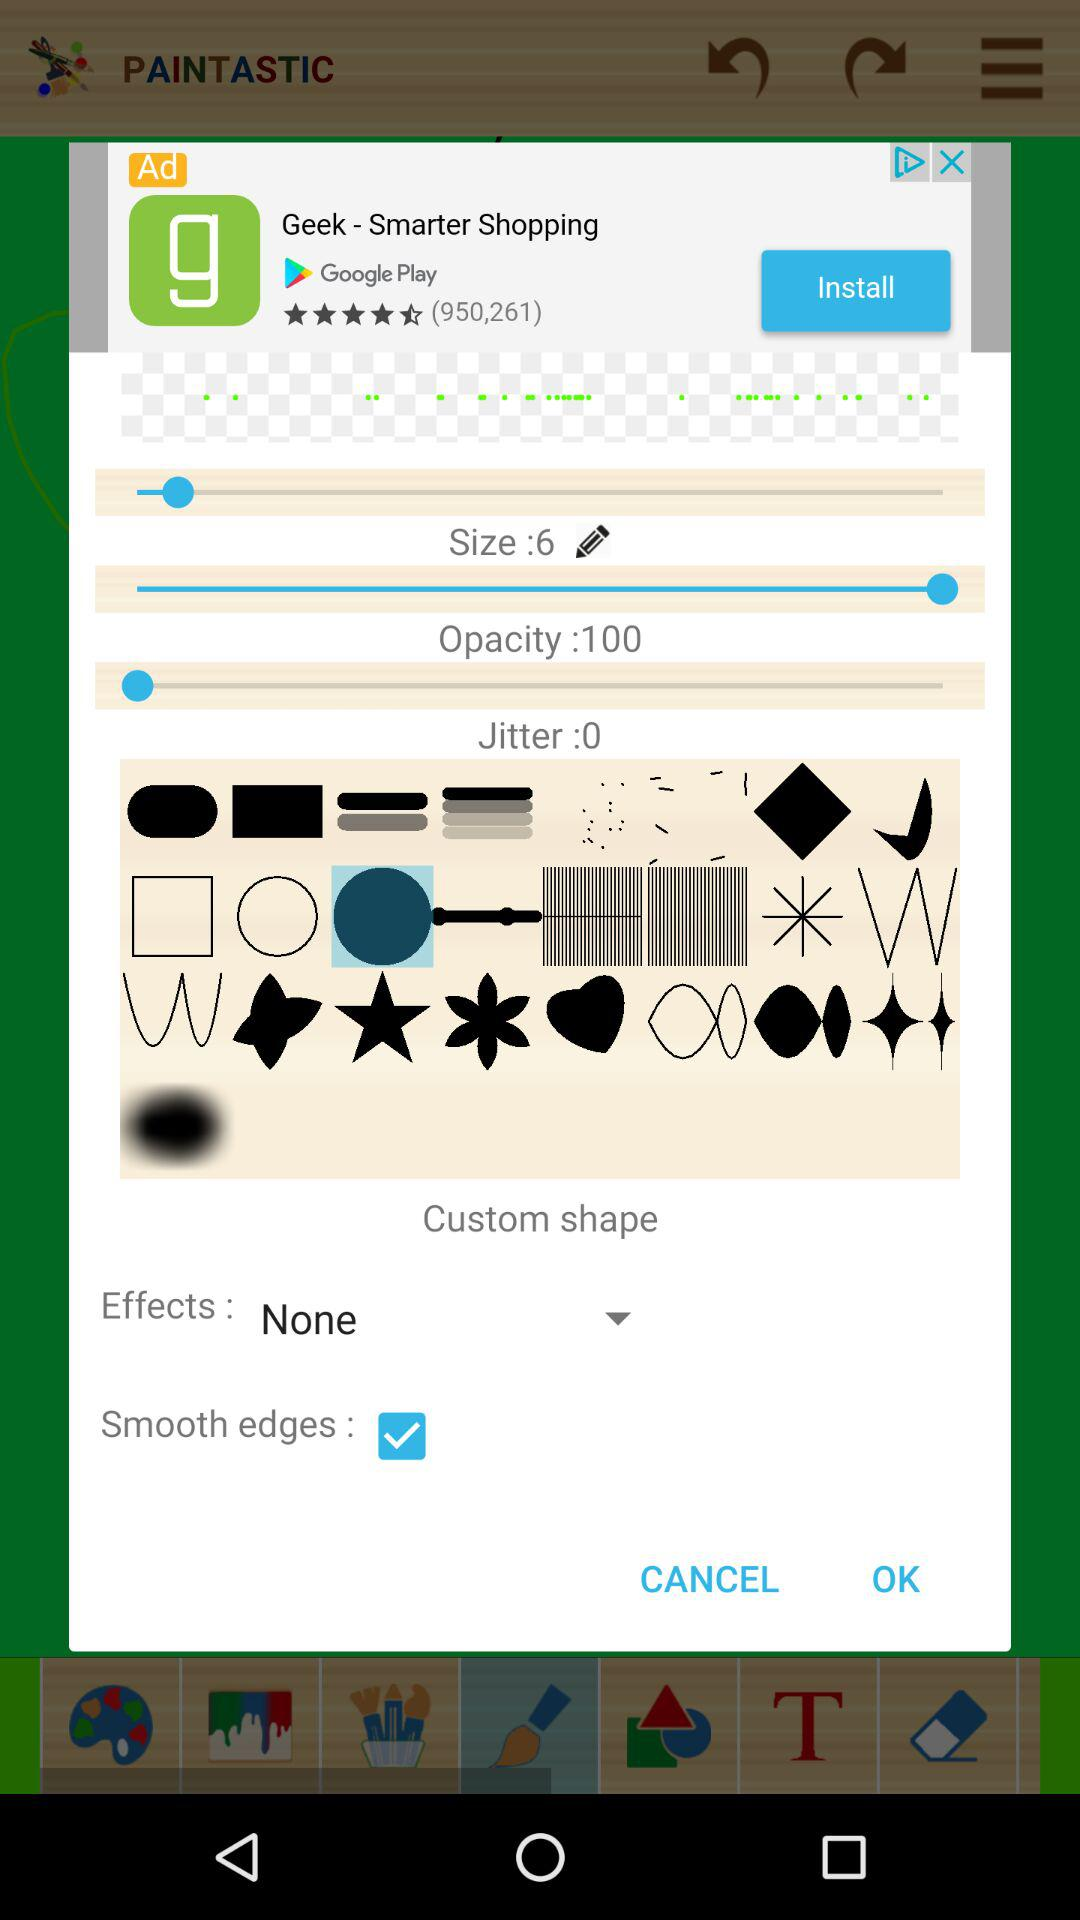What is the current status of the "Smooth edges"? The current status is on. 